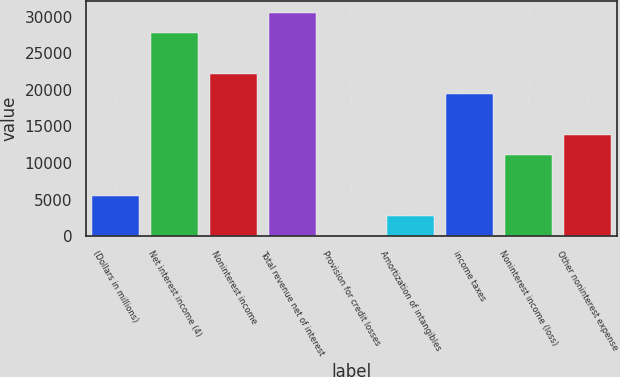Convert chart to OTSL. <chart><loc_0><loc_0><loc_500><loc_500><bar_chart><fcel>(Dollars in millions)<fcel>Net interest income (4)<fcel>Noninterest income<fcel>Total revenue net of interest<fcel>Provision for credit losses<fcel>Amortization of intangibles<fcel>income taxes<fcel>Noninterest income (loss)<fcel>Other noninterest expense<nl><fcel>5556.2<fcel>27773<fcel>22218.8<fcel>30550.1<fcel>2<fcel>2779.1<fcel>19441.7<fcel>11110.4<fcel>13887.5<nl></chart> 